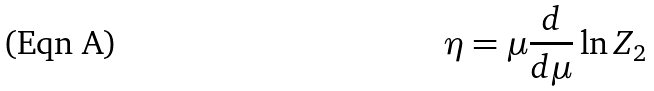Convert formula to latex. <formula><loc_0><loc_0><loc_500><loc_500>\eta = \mu \frac { d } { d \mu } \ln Z _ { 2 }</formula> 